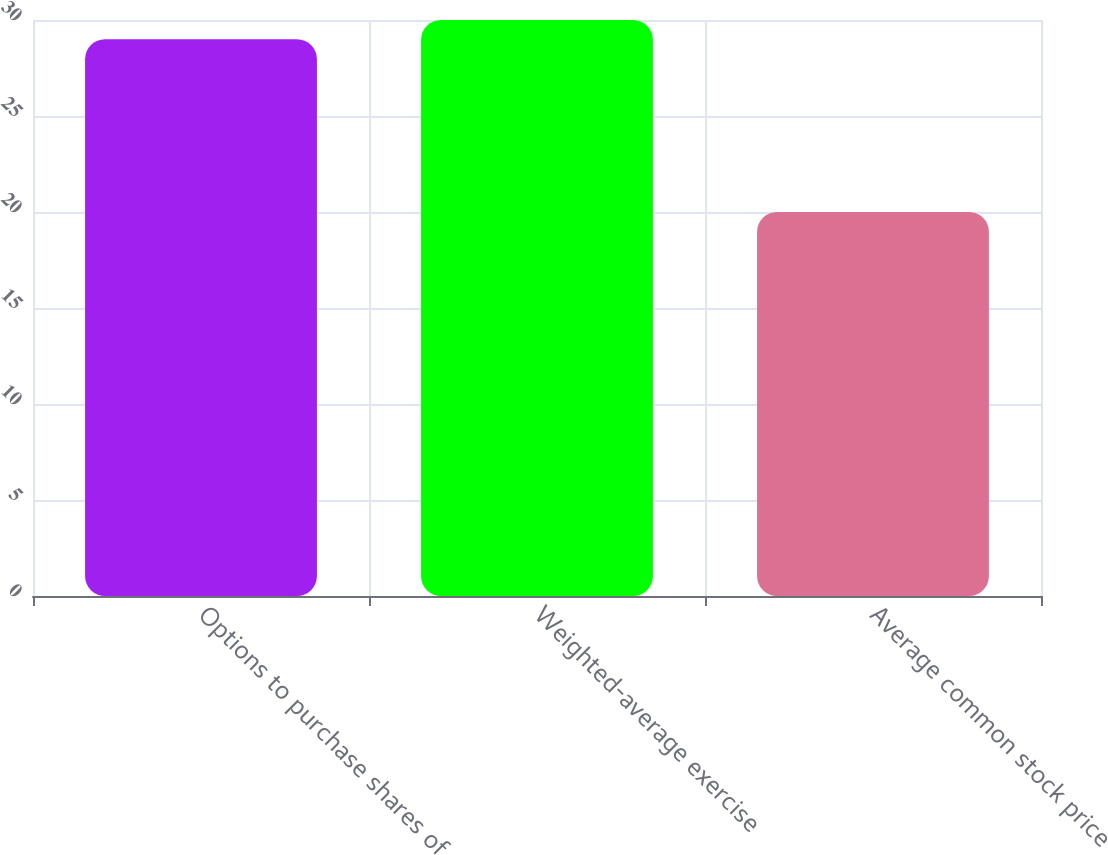Convert chart. <chart><loc_0><loc_0><loc_500><loc_500><bar_chart><fcel>Options to purchase shares of<fcel>Weighted-average exercise<fcel>Average common stock price<nl><fcel>29<fcel>30<fcel>20<nl></chart> 